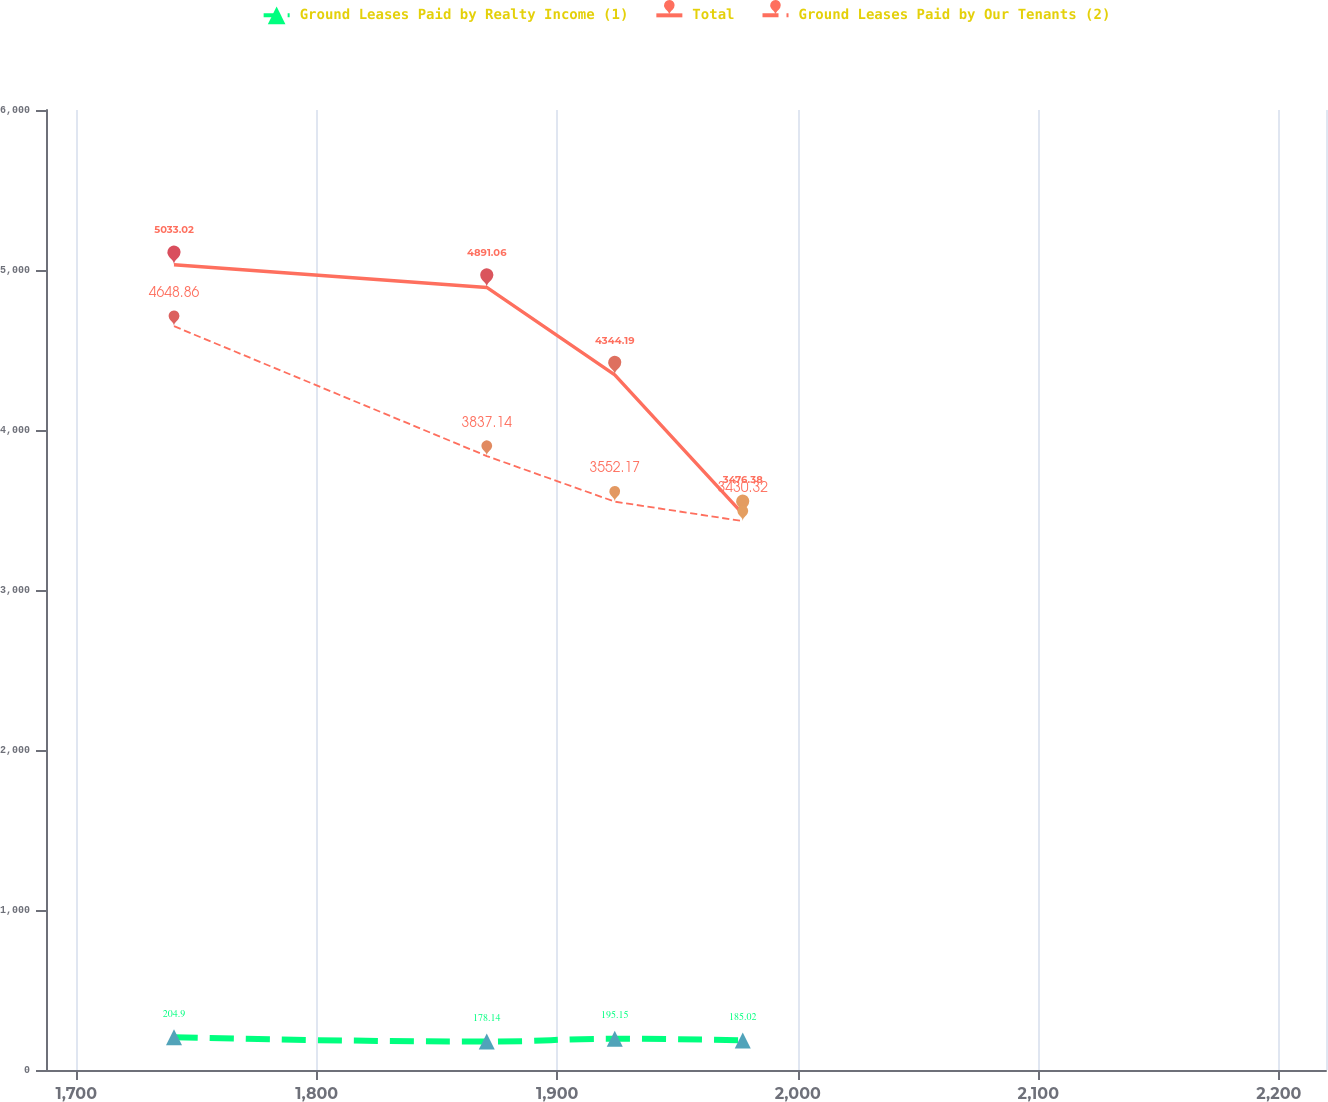<chart> <loc_0><loc_0><loc_500><loc_500><line_chart><ecel><fcel>Ground Leases Paid by Realty Income (1)<fcel>Total<fcel>Ground Leases Paid by Our Tenants (2)<nl><fcel>1740.64<fcel>204.9<fcel>5033.02<fcel>4648.86<nl><fcel>1870.68<fcel>178.14<fcel>4891.06<fcel>3837.14<nl><fcel>1923.9<fcel>195.15<fcel>4344.19<fcel>3552.17<nl><fcel>1977.12<fcel>185.02<fcel>3476.38<fcel>3430.32<nl><fcel>2272.83<fcel>229.29<fcel>3618.34<fcel>4509.02<nl></chart> 